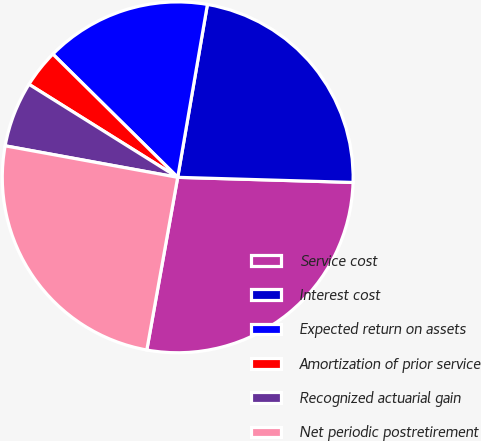Convert chart to OTSL. <chart><loc_0><loc_0><loc_500><loc_500><pie_chart><fcel>Service cost<fcel>Interest cost<fcel>Expected return on assets<fcel>Amortization of prior service<fcel>Recognized actuarial gain<fcel>Net periodic postretirement<nl><fcel>27.35%<fcel>22.75%<fcel>15.31%<fcel>3.5%<fcel>6.02%<fcel>25.05%<nl></chart> 